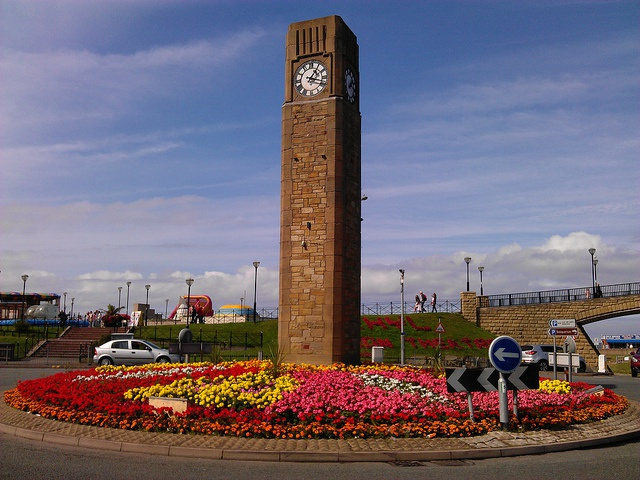Describe the objects in this image and their specific colors. I can see car in gray, black, darkgray, and lightgray tones, clock in gray, lightgray, black, and darkgray tones, car in gray, black, darkgray, and lightgray tones, car in gray, darkgray, orange, and black tones, and clock in gray, black, purple, and darkblue tones in this image. 